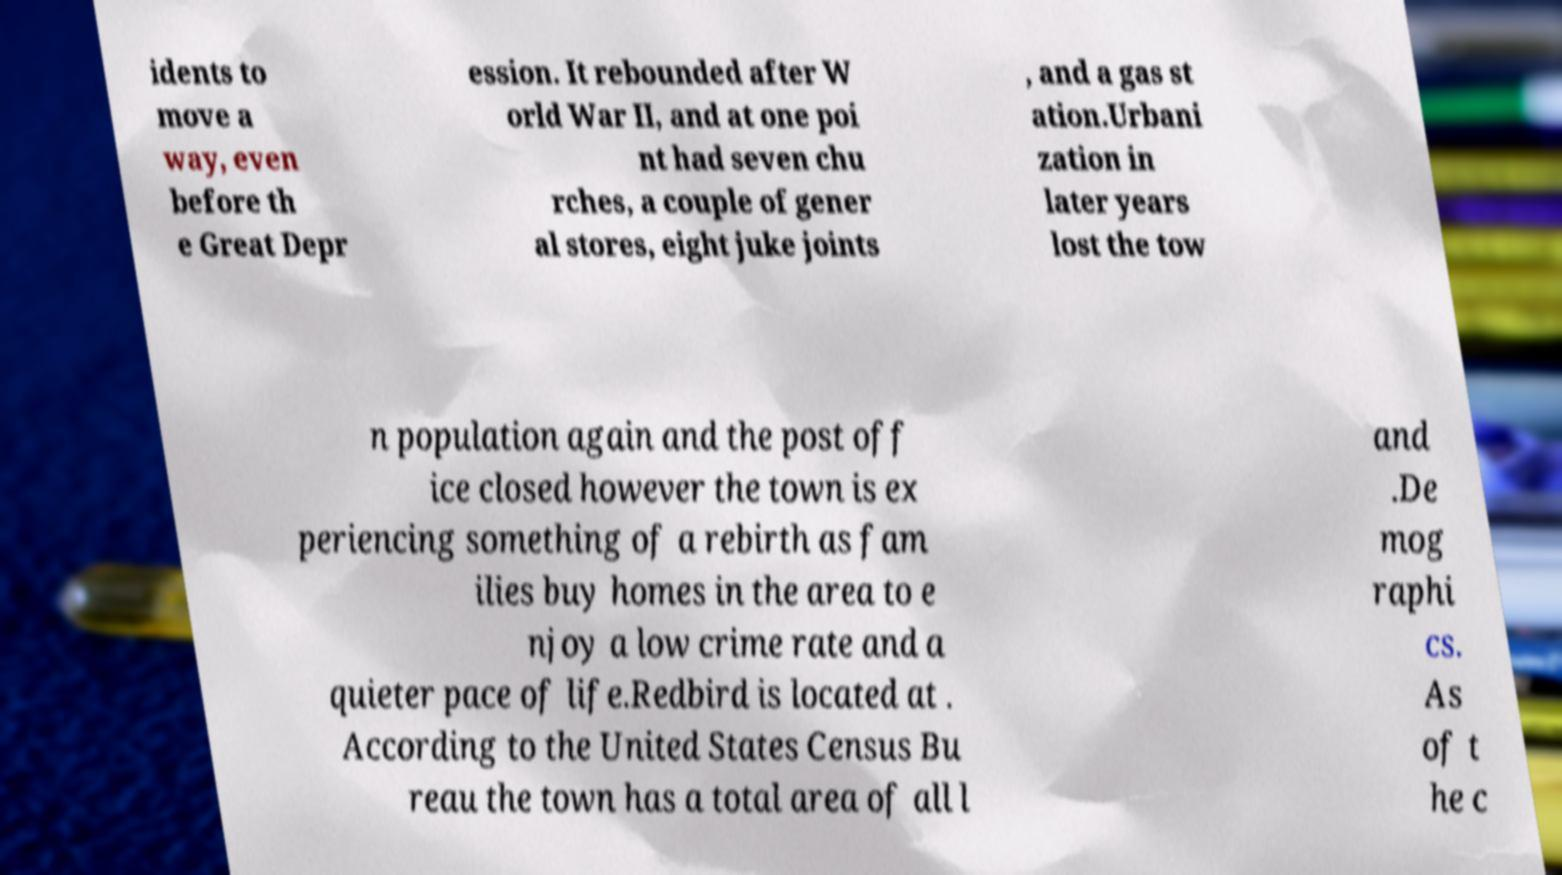Please identify and transcribe the text found in this image. idents to move a way, even before th e Great Depr ession. It rebounded after W orld War II, and at one poi nt had seven chu rches, a couple of gener al stores, eight juke joints , and a gas st ation.Urbani zation in later years lost the tow n population again and the post off ice closed however the town is ex periencing something of a rebirth as fam ilies buy homes in the area to e njoy a low crime rate and a quieter pace of life.Redbird is located at . According to the United States Census Bu reau the town has a total area of all l and .De mog raphi cs. As of t he c 